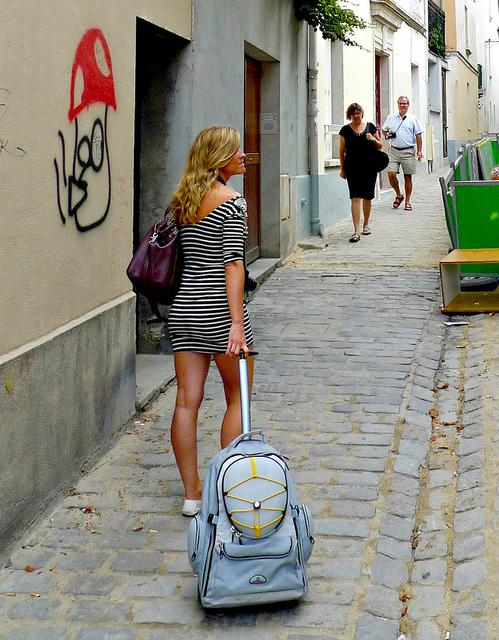Where might the lady on the sidewalk be going?

Choices:
A) vacation
B) protest
C) work
D) sales job vacation 